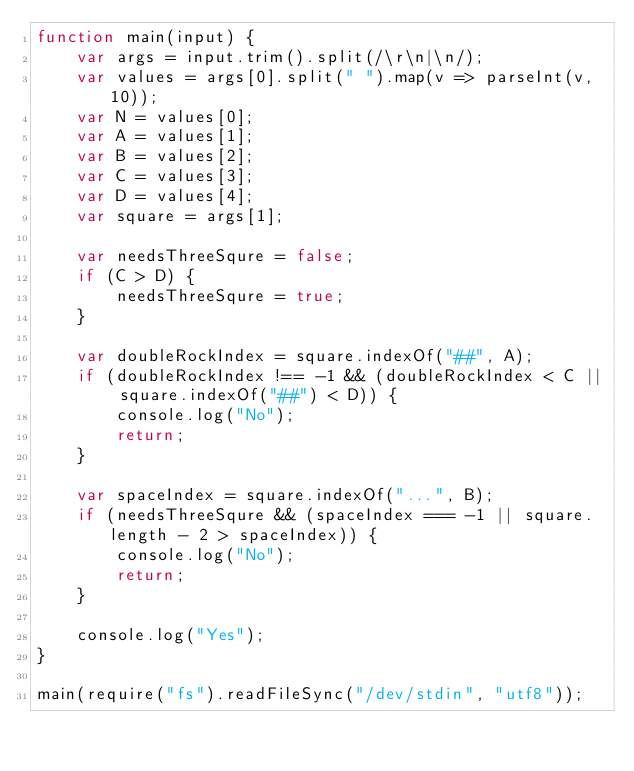Convert code to text. <code><loc_0><loc_0><loc_500><loc_500><_JavaScript_>function main(input) {
    var args = input.trim().split(/\r\n|\n/);
    var values = args[0].split(" ").map(v => parseInt(v, 10));
    var N = values[0];
    var A = values[1];
    var B = values[2];
    var C = values[3];
    var D = values[4];
    var square = args[1];

    var needsThreeSqure = false;
    if (C > D) {
        needsThreeSqure = true;
    }

    var doubleRockIndex = square.indexOf("##", A);
    if (doubleRockIndex !== -1 && (doubleRockIndex < C || square.indexOf("##") < D)) {
        console.log("No");
        return;
    }

    var spaceIndex = square.indexOf("...", B);
    if (needsThreeSqure && (spaceIndex === -1 || square.length - 2 > spaceIndex)) {
        console.log("No");
        return;
    }

    console.log("Yes");
}

main(require("fs").readFileSync("/dev/stdin", "utf8"));</code> 